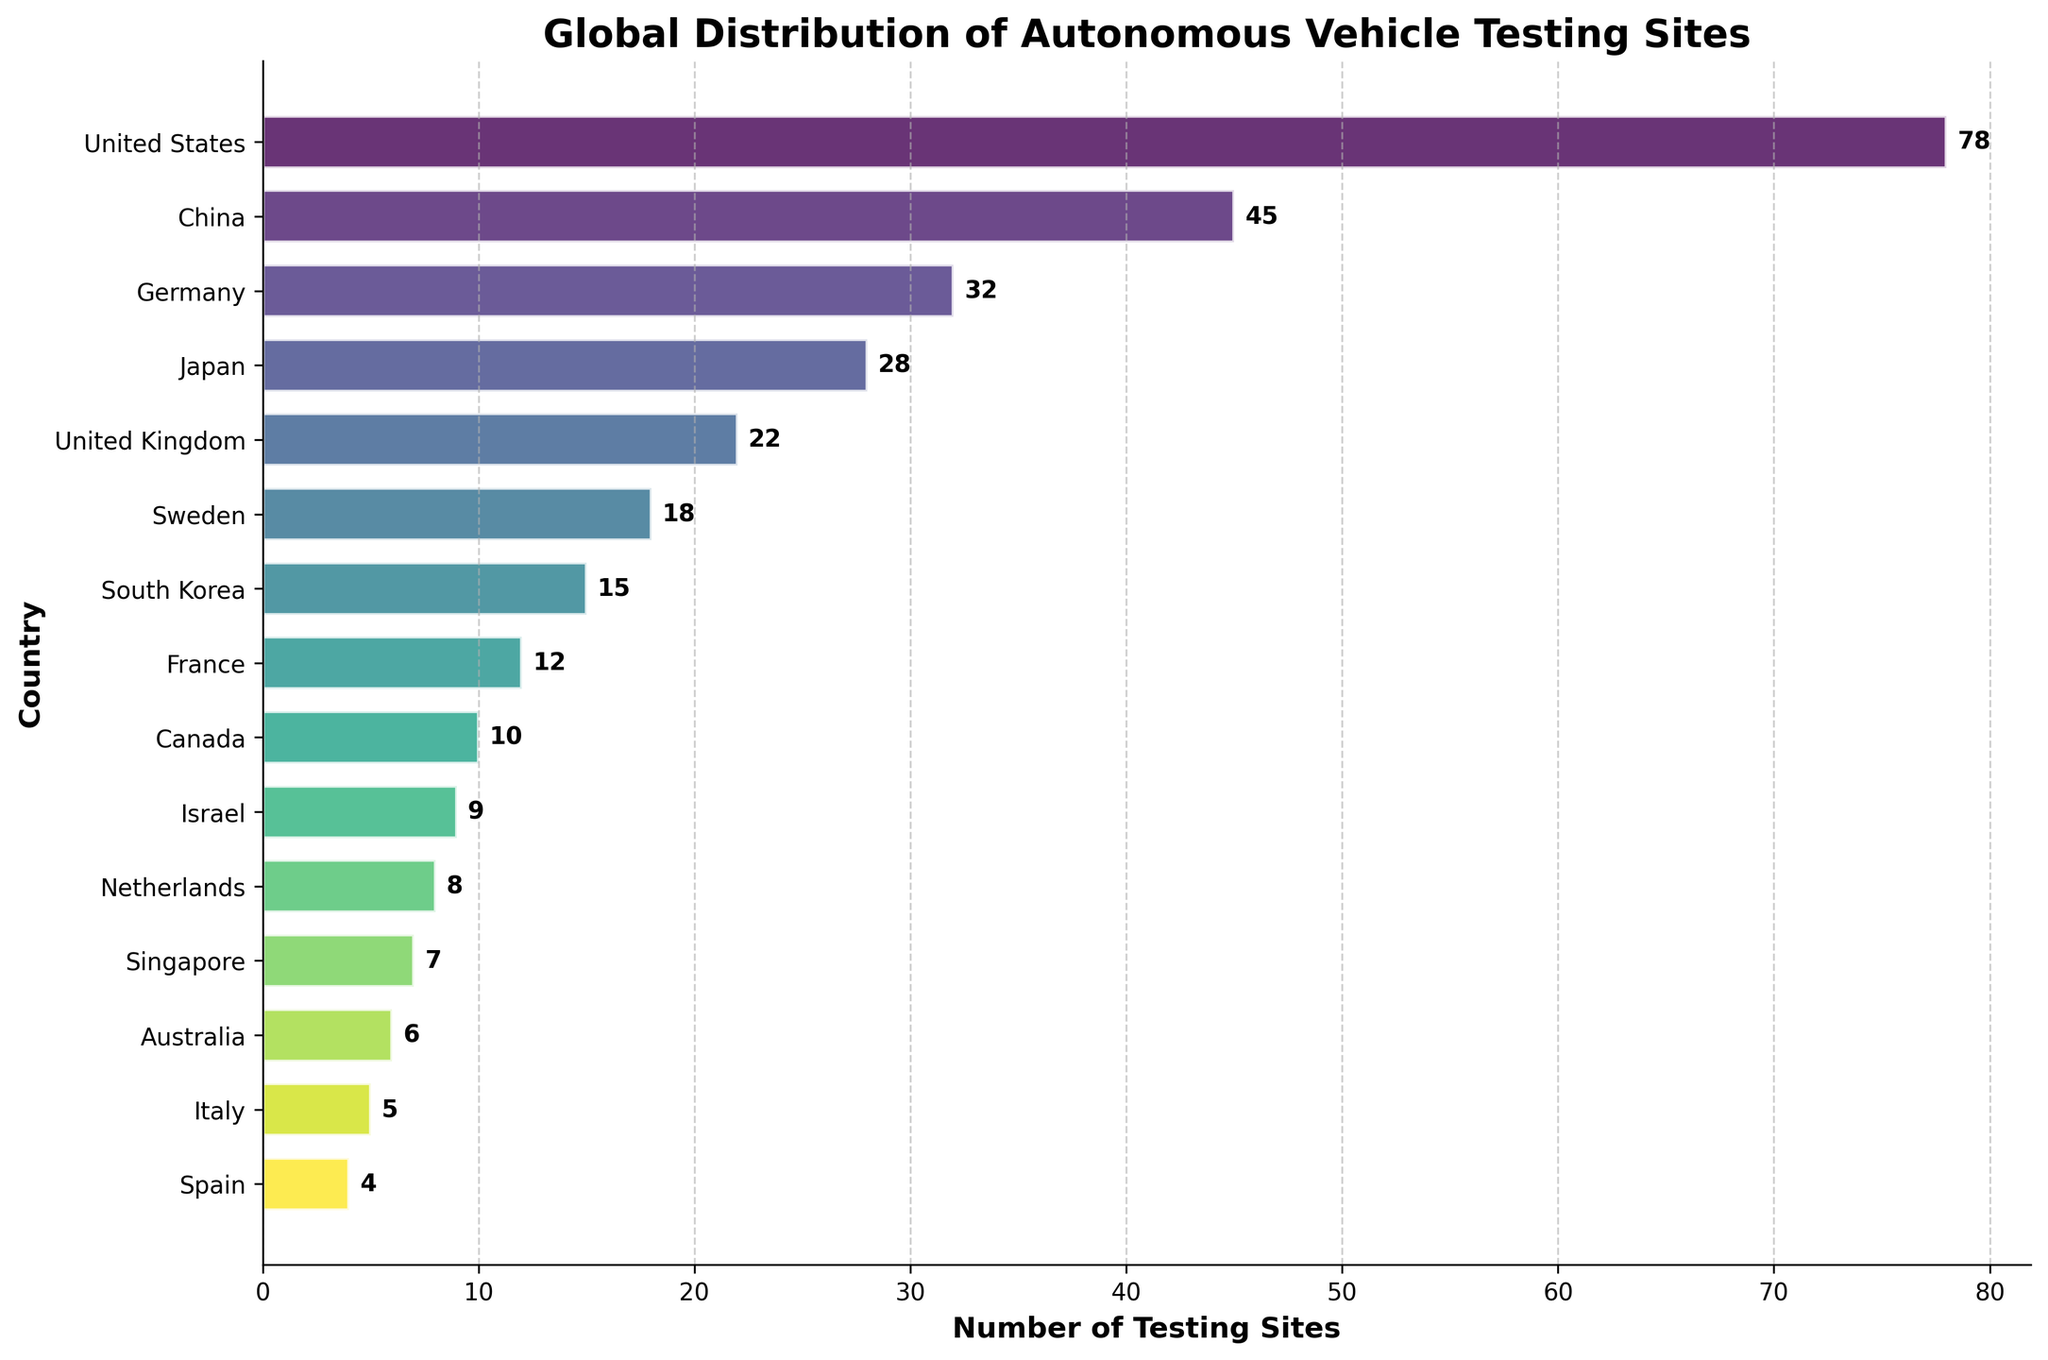What is the title of the plot? The title is displayed at the top of the figure.
Answer: Global Distribution of Autonomous Vehicle Testing Sites Which country has the highest number of autonomous vehicle testing sites? The United States bar is the longest, indicating it has the highest number.
Answer: United States How many testing sites does China have? The number next to China's bar indicates the count of testing sites.
Answer: 45 What countries have more than 20 testing sites? Identify which bars extend beyond the 20 testing sites mark and read their labels.
Answer: United States, China, Germany, Japan, United Kingdom What is the combined number of testing sites in Germany and Japan? Add the number of testing sites for Germany (32) and Japan (28).
Answer: 60 Which country has more testing sites, Sweden or South Korea? Compare the lengths of the bars for Sweden and South Korea, reading the numbers next to them.
Answer: Sweden What color scheme is used in the plot? The color gradient seen in the bars suggests a colormap, and given the smooth blend from one color to another, it's likely a perceptually uniform colormap like Viridis.
Answer: Viridis How many countries have fewer than 10 testing sites? Count the bars for countries listed with single-digit numbers.
Answer: 5 Is the number of testing sites in France greater than that in Israel? Compare the lengths of the bars for France and Israel. Observe that France's bar is longer.
Answer: Yes What is the range of the number of testing sites among the countries listed? Subtract the smallest number of testing sites (4 for Spain) from the largest (78 for the United States).
Answer: 74 